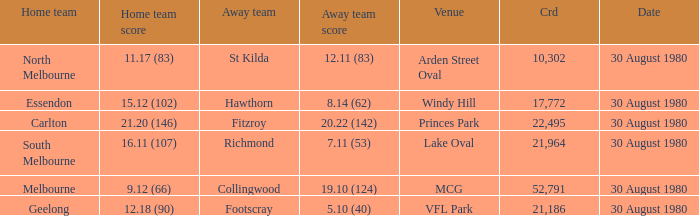What is the home team score at lake oval? 16.11 (107). 